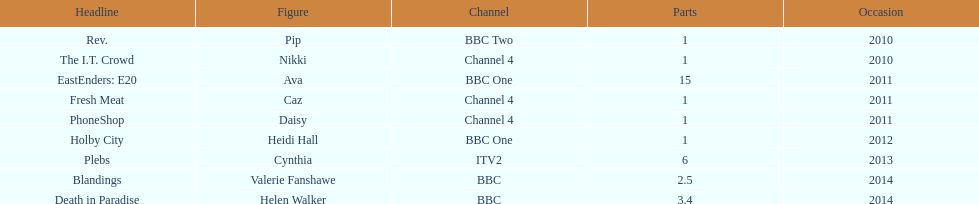How many titles only had one episode? 5. Give me the full table as a dictionary. {'header': ['Headline', 'Figure', 'Channel', 'Parts', 'Occasion'], 'rows': [['Rev.', 'Pip', 'BBC Two', '1', '2010'], ['The I.T. Crowd', 'Nikki', 'Channel 4', '1', '2010'], ['EastEnders: E20', 'Ava', 'BBC One', '15', '2011'], ['Fresh Meat', 'Caz', 'Channel 4', '1', '2011'], ['PhoneShop', 'Daisy', 'Channel 4', '1', '2011'], ['Holby City', 'Heidi Hall', 'BBC One', '1', '2012'], ['Plebs', 'Cynthia', 'ITV2', '6', '2013'], ['Blandings', 'Valerie Fanshawe', 'BBC', '2.5', '2014'], ['Death in Paradise', 'Helen Walker', 'BBC', '3.4', '2014']]} 